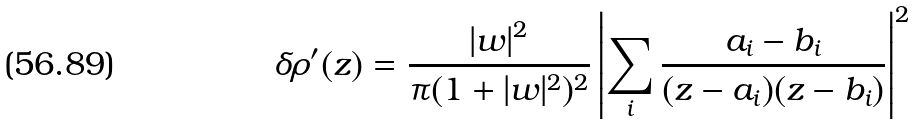Convert formula to latex. <formula><loc_0><loc_0><loc_500><loc_500>\delta \rho ^ { \prime } ( z ) = \frac { | w | ^ { 2 } } { \pi ( 1 + | w | ^ { 2 } ) ^ { 2 } } \left | \sum _ { i } \frac { a _ { i } - b _ { i } } { ( z - a _ { i } ) ( z - b _ { i } ) } \right | ^ { 2 }</formula> 